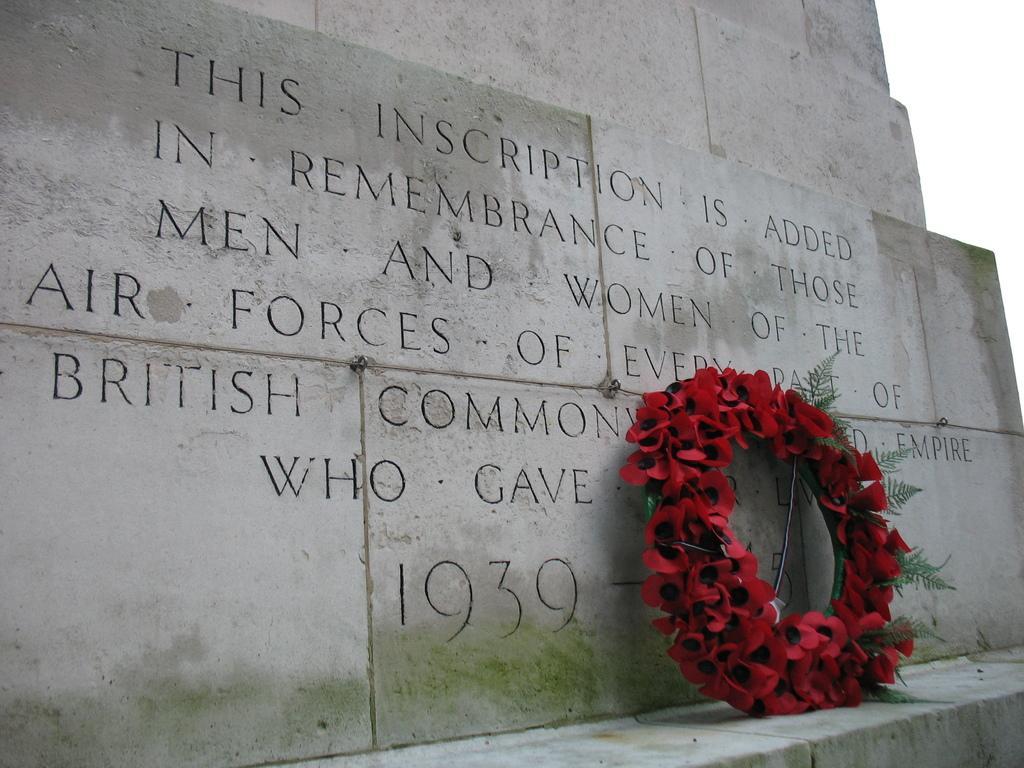How would you summarize this image in a sentence or two? In this image in the front there is a bouquet of roses. In the background there is a wall with some text written on it and the sky is cloudy. 